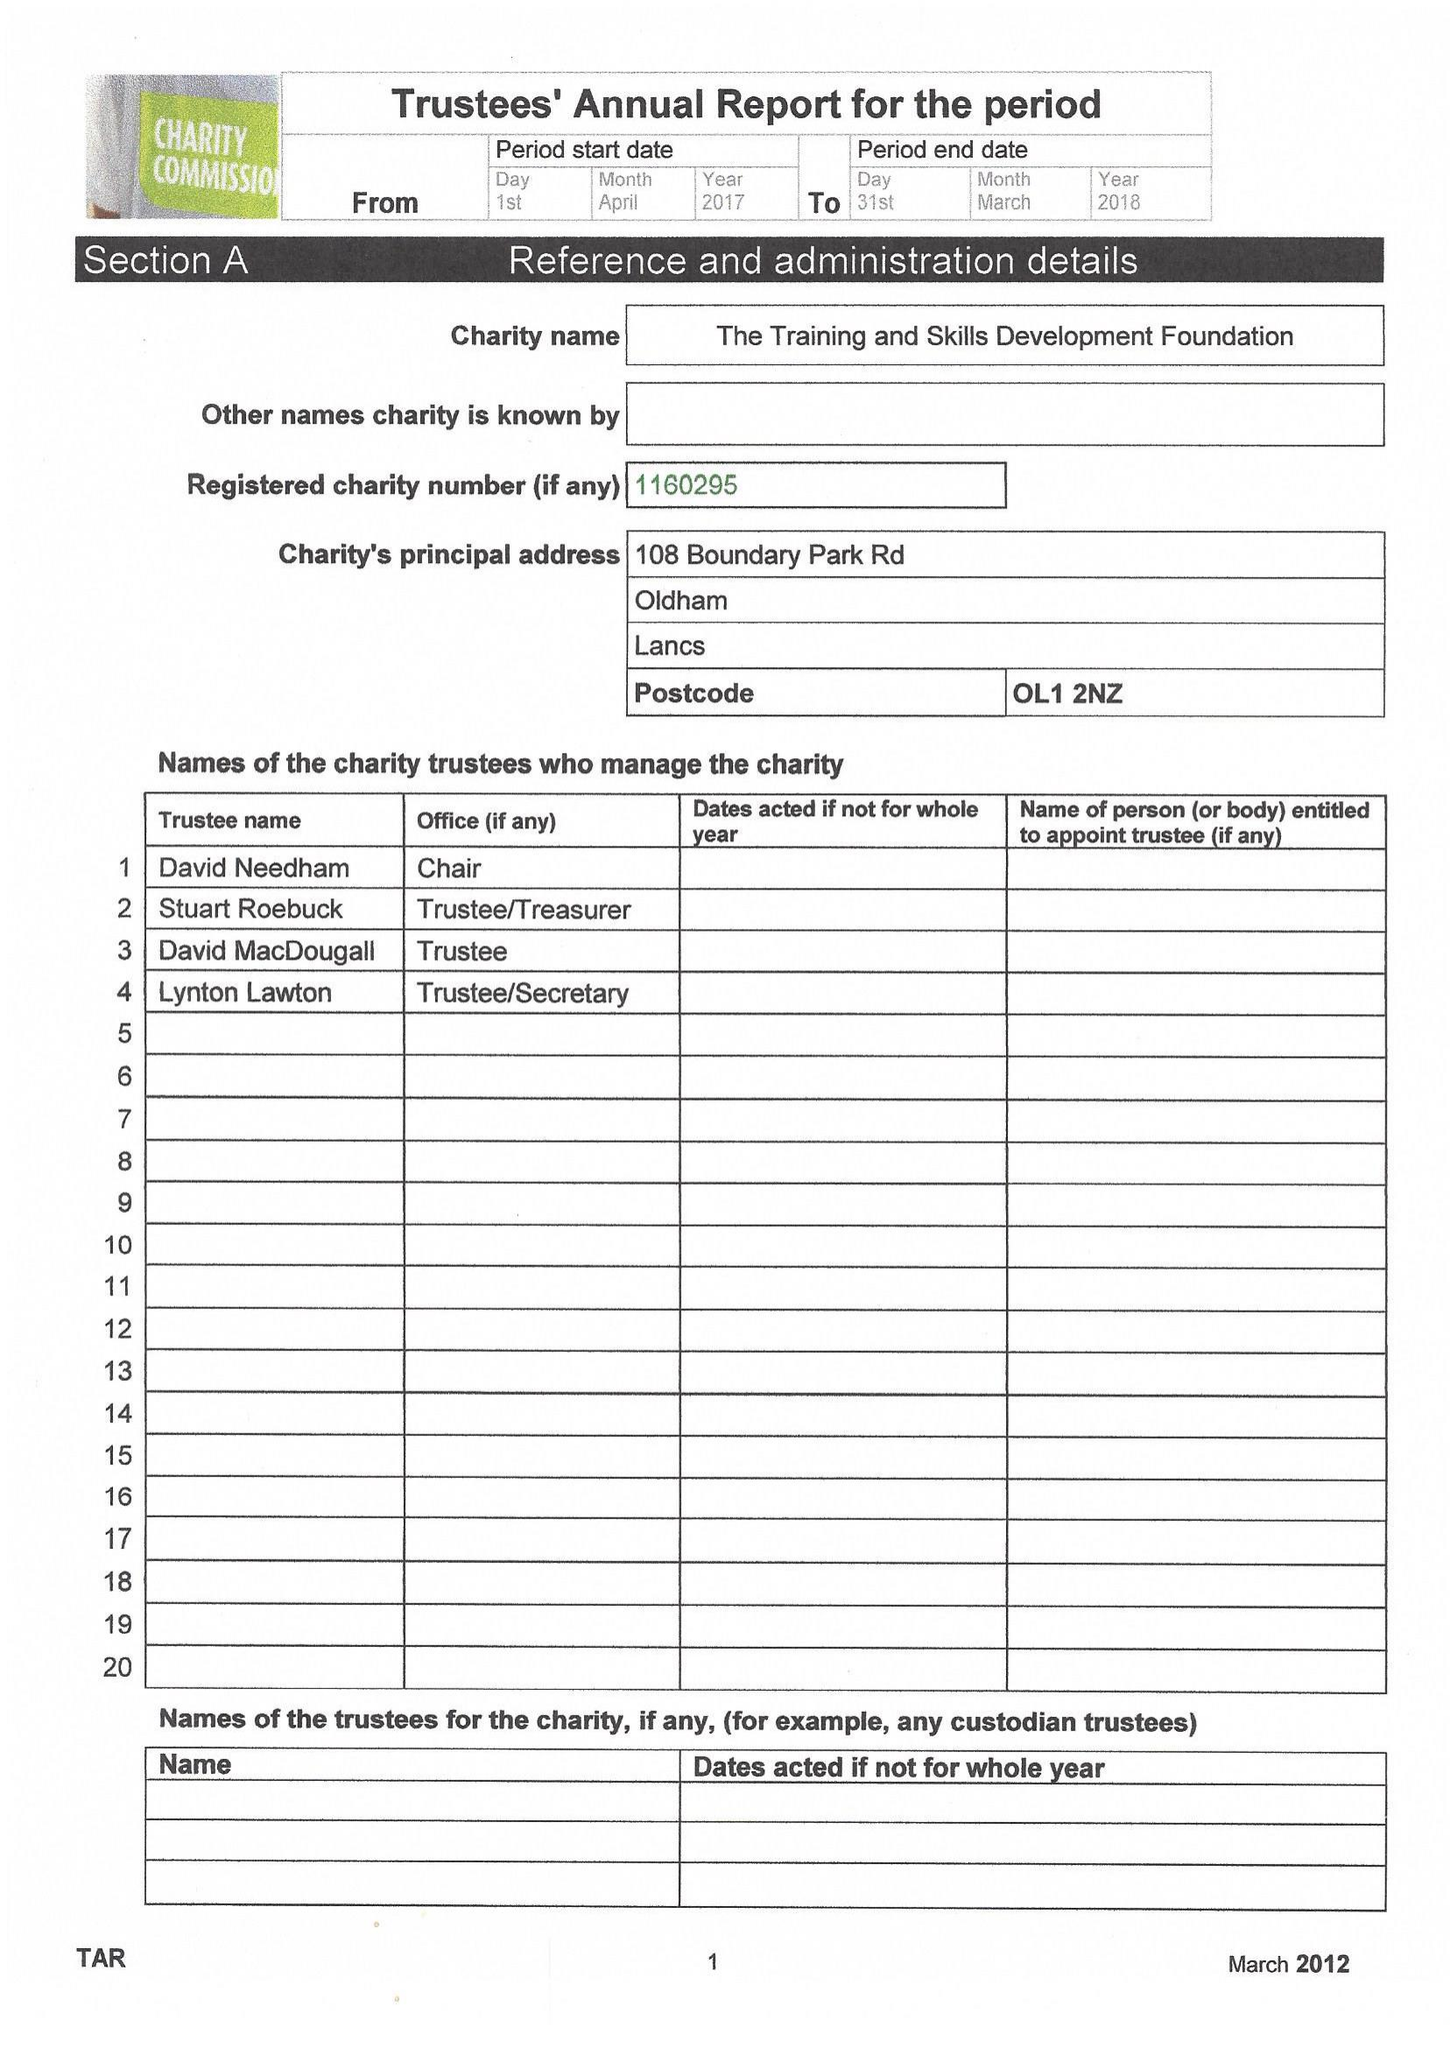What is the value for the address__street_line?
Answer the question using a single word or phrase. 108 BOUNDARY PARK ROAD 